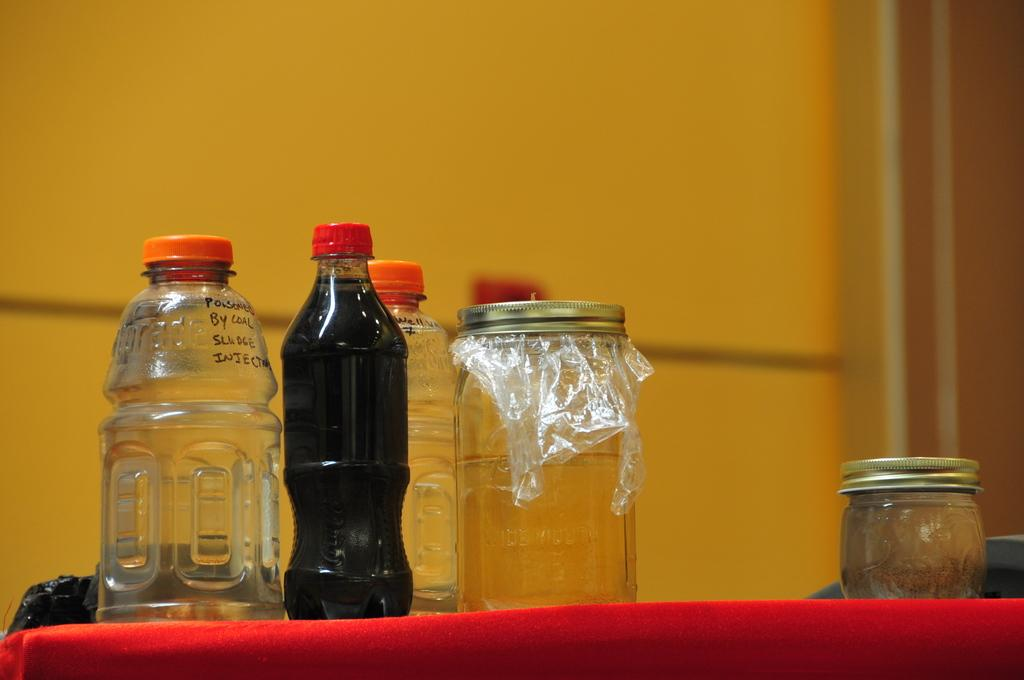<image>
Share a concise interpretation of the image provided. A collection of clear bottles, one of which is labeled as being poisoned. 